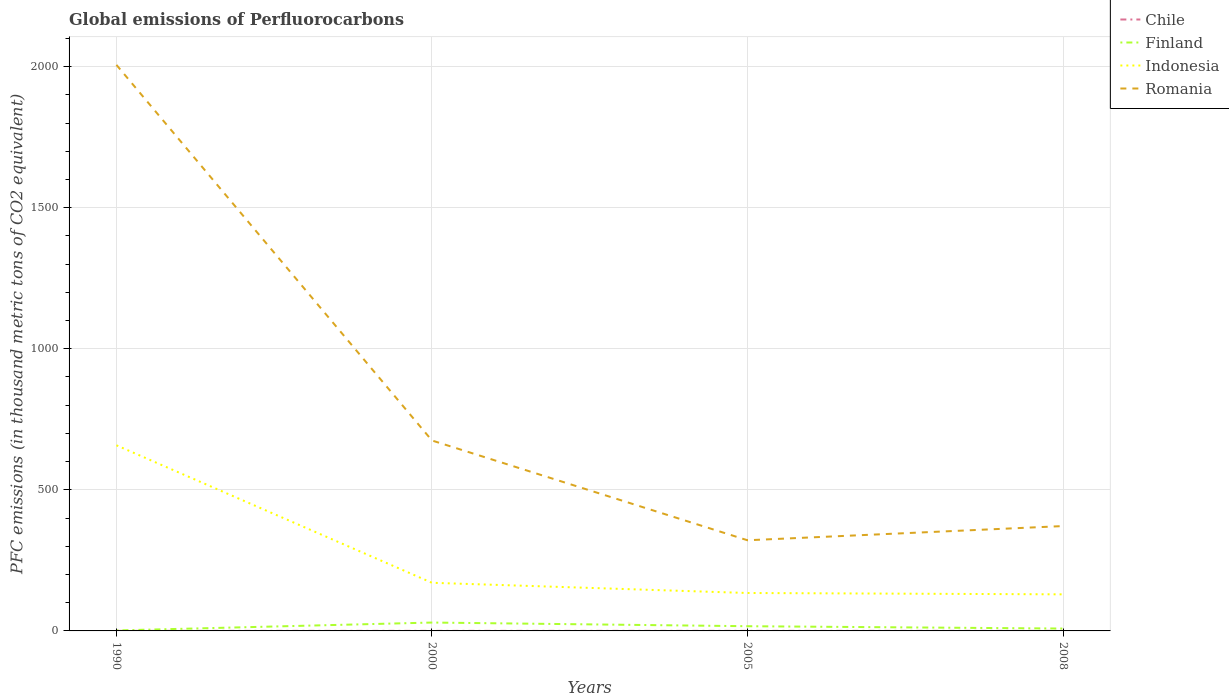How many different coloured lines are there?
Provide a short and direct response. 4. What is the total global emissions of Perfluorocarbons in Romania in the graph?
Your response must be concise. 353.6. What is the difference between the highest and the second highest global emissions of Perfluorocarbons in Finland?
Offer a terse response. 28. What is the difference between the highest and the lowest global emissions of Perfluorocarbons in Finland?
Keep it short and to the point. 2. How many lines are there?
Ensure brevity in your answer.  4. What is the difference between two consecutive major ticks on the Y-axis?
Your response must be concise. 500. Does the graph contain any zero values?
Ensure brevity in your answer.  No. What is the title of the graph?
Your response must be concise. Global emissions of Perfluorocarbons. What is the label or title of the X-axis?
Give a very brief answer. Years. What is the label or title of the Y-axis?
Offer a terse response. PFC emissions (in thousand metric tons of CO2 equivalent). What is the PFC emissions (in thousand metric tons of CO2 equivalent) in Chile in 1990?
Ensure brevity in your answer.  0.2. What is the PFC emissions (in thousand metric tons of CO2 equivalent) in Finland in 1990?
Keep it short and to the point. 1.7. What is the PFC emissions (in thousand metric tons of CO2 equivalent) in Indonesia in 1990?
Offer a very short reply. 657.9. What is the PFC emissions (in thousand metric tons of CO2 equivalent) of Romania in 1990?
Make the answer very short. 2006.1. What is the PFC emissions (in thousand metric tons of CO2 equivalent) of Chile in 2000?
Your answer should be very brief. 0.2. What is the PFC emissions (in thousand metric tons of CO2 equivalent) in Finland in 2000?
Your answer should be very brief. 29.7. What is the PFC emissions (in thousand metric tons of CO2 equivalent) of Indonesia in 2000?
Your answer should be compact. 170.6. What is the PFC emissions (in thousand metric tons of CO2 equivalent) in Romania in 2000?
Provide a short and direct response. 674.9. What is the PFC emissions (in thousand metric tons of CO2 equivalent) in Chile in 2005?
Your answer should be compact. 0.2. What is the PFC emissions (in thousand metric tons of CO2 equivalent) in Indonesia in 2005?
Your answer should be compact. 134.4. What is the PFC emissions (in thousand metric tons of CO2 equivalent) of Romania in 2005?
Ensure brevity in your answer.  321.3. What is the PFC emissions (in thousand metric tons of CO2 equivalent) of Finland in 2008?
Keep it short and to the point. 8.4. What is the PFC emissions (in thousand metric tons of CO2 equivalent) in Indonesia in 2008?
Give a very brief answer. 129.6. What is the PFC emissions (in thousand metric tons of CO2 equivalent) in Romania in 2008?
Provide a short and direct response. 371.6. Across all years, what is the maximum PFC emissions (in thousand metric tons of CO2 equivalent) in Chile?
Ensure brevity in your answer.  0.2. Across all years, what is the maximum PFC emissions (in thousand metric tons of CO2 equivalent) in Finland?
Ensure brevity in your answer.  29.7. Across all years, what is the maximum PFC emissions (in thousand metric tons of CO2 equivalent) in Indonesia?
Provide a short and direct response. 657.9. Across all years, what is the maximum PFC emissions (in thousand metric tons of CO2 equivalent) of Romania?
Keep it short and to the point. 2006.1. Across all years, what is the minimum PFC emissions (in thousand metric tons of CO2 equivalent) in Chile?
Your answer should be very brief. 0.2. Across all years, what is the minimum PFC emissions (in thousand metric tons of CO2 equivalent) of Finland?
Offer a very short reply. 1.7. Across all years, what is the minimum PFC emissions (in thousand metric tons of CO2 equivalent) of Indonesia?
Keep it short and to the point. 129.6. Across all years, what is the minimum PFC emissions (in thousand metric tons of CO2 equivalent) in Romania?
Offer a terse response. 321.3. What is the total PFC emissions (in thousand metric tons of CO2 equivalent) in Chile in the graph?
Your response must be concise. 0.8. What is the total PFC emissions (in thousand metric tons of CO2 equivalent) of Finland in the graph?
Make the answer very short. 56.5. What is the total PFC emissions (in thousand metric tons of CO2 equivalent) of Indonesia in the graph?
Keep it short and to the point. 1092.5. What is the total PFC emissions (in thousand metric tons of CO2 equivalent) in Romania in the graph?
Give a very brief answer. 3373.9. What is the difference between the PFC emissions (in thousand metric tons of CO2 equivalent) in Finland in 1990 and that in 2000?
Provide a succinct answer. -28. What is the difference between the PFC emissions (in thousand metric tons of CO2 equivalent) of Indonesia in 1990 and that in 2000?
Provide a short and direct response. 487.3. What is the difference between the PFC emissions (in thousand metric tons of CO2 equivalent) in Romania in 1990 and that in 2000?
Make the answer very short. 1331.2. What is the difference between the PFC emissions (in thousand metric tons of CO2 equivalent) in Chile in 1990 and that in 2005?
Your answer should be very brief. 0. What is the difference between the PFC emissions (in thousand metric tons of CO2 equivalent) in Finland in 1990 and that in 2005?
Your response must be concise. -15. What is the difference between the PFC emissions (in thousand metric tons of CO2 equivalent) of Indonesia in 1990 and that in 2005?
Provide a short and direct response. 523.5. What is the difference between the PFC emissions (in thousand metric tons of CO2 equivalent) of Romania in 1990 and that in 2005?
Provide a short and direct response. 1684.8. What is the difference between the PFC emissions (in thousand metric tons of CO2 equivalent) in Finland in 1990 and that in 2008?
Keep it short and to the point. -6.7. What is the difference between the PFC emissions (in thousand metric tons of CO2 equivalent) of Indonesia in 1990 and that in 2008?
Ensure brevity in your answer.  528.3. What is the difference between the PFC emissions (in thousand metric tons of CO2 equivalent) of Romania in 1990 and that in 2008?
Ensure brevity in your answer.  1634.5. What is the difference between the PFC emissions (in thousand metric tons of CO2 equivalent) in Indonesia in 2000 and that in 2005?
Provide a succinct answer. 36.2. What is the difference between the PFC emissions (in thousand metric tons of CO2 equivalent) of Romania in 2000 and that in 2005?
Your answer should be compact. 353.6. What is the difference between the PFC emissions (in thousand metric tons of CO2 equivalent) of Finland in 2000 and that in 2008?
Your response must be concise. 21.3. What is the difference between the PFC emissions (in thousand metric tons of CO2 equivalent) of Indonesia in 2000 and that in 2008?
Provide a succinct answer. 41. What is the difference between the PFC emissions (in thousand metric tons of CO2 equivalent) of Romania in 2000 and that in 2008?
Provide a succinct answer. 303.3. What is the difference between the PFC emissions (in thousand metric tons of CO2 equivalent) of Chile in 2005 and that in 2008?
Make the answer very short. 0. What is the difference between the PFC emissions (in thousand metric tons of CO2 equivalent) of Finland in 2005 and that in 2008?
Your response must be concise. 8.3. What is the difference between the PFC emissions (in thousand metric tons of CO2 equivalent) of Romania in 2005 and that in 2008?
Your answer should be very brief. -50.3. What is the difference between the PFC emissions (in thousand metric tons of CO2 equivalent) in Chile in 1990 and the PFC emissions (in thousand metric tons of CO2 equivalent) in Finland in 2000?
Provide a short and direct response. -29.5. What is the difference between the PFC emissions (in thousand metric tons of CO2 equivalent) in Chile in 1990 and the PFC emissions (in thousand metric tons of CO2 equivalent) in Indonesia in 2000?
Offer a very short reply. -170.4. What is the difference between the PFC emissions (in thousand metric tons of CO2 equivalent) in Chile in 1990 and the PFC emissions (in thousand metric tons of CO2 equivalent) in Romania in 2000?
Ensure brevity in your answer.  -674.7. What is the difference between the PFC emissions (in thousand metric tons of CO2 equivalent) in Finland in 1990 and the PFC emissions (in thousand metric tons of CO2 equivalent) in Indonesia in 2000?
Your answer should be very brief. -168.9. What is the difference between the PFC emissions (in thousand metric tons of CO2 equivalent) of Finland in 1990 and the PFC emissions (in thousand metric tons of CO2 equivalent) of Romania in 2000?
Keep it short and to the point. -673.2. What is the difference between the PFC emissions (in thousand metric tons of CO2 equivalent) of Chile in 1990 and the PFC emissions (in thousand metric tons of CO2 equivalent) of Finland in 2005?
Offer a very short reply. -16.5. What is the difference between the PFC emissions (in thousand metric tons of CO2 equivalent) of Chile in 1990 and the PFC emissions (in thousand metric tons of CO2 equivalent) of Indonesia in 2005?
Provide a short and direct response. -134.2. What is the difference between the PFC emissions (in thousand metric tons of CO2 equivalent) of Chile in 1990 and the PFC emissions (in thousand metric tons of CO2 equivalent) of Romania in 2005?
Keep it short and to the point. -321.1. What is the difference between the PFC emissions (in thousand metric tons of CO2 equivalent) of Finland in 1990 and the PFC emissions (in thousand metric tons of CO2 equivalent) of Indonesia in 2005?
Your response must be concise. -132.7. What is the difference between the PFC emissions (in thousand metric tons of CO2 equivalent) in Finland in 1990 and the PFC emissions (in thousand metric tons of CO2 equivalent) in Romania in 2005?
Provide a short and direct response. -319.6. What is the difference between the PFC emissions (in thousand metric tons of CO2 equivalent) in Indonesia in 1990 and the PFC emissions (in thousand metric tons of CO2 equivalent) in Romania in 2005?
Provide a succinct answer. 336.6. What is the difference between the PFC emissions (in thousand metric tons of CO2 equivalent) of Chile in 1990 and the PFC emissions (in thousand metric tons of CO2 equivalent) of Indonesia in 2008?
Keep it short and to the point. -129.4. What is the difference between the PFC emissions (in thousand metric tons of CO2 equivalent) of Chile in 1990 and the PFC emissions (in thousand metric tons of CO2 equivalent) of Romania in 2008?
Ensure brevity in your answer.  -371.4. What is the difference between the PFC emissions (in thousand metric tons of CO2 equivalent) of Finland in 1990 and the PFC emissions (in thousand metric tons of CO2 equivalent) of Indonesia in 2008?
Keep it short and to the point. -127.9. What is the difference between the PFC emissions (in thousand metric tons of CO2 equivalent) of Finland in 1990 and the PFC emissions (in thousand metric tons of CO2 equivalent) of Romania in 2008?
Offer a very short reply. -369.9. What is the difference between the PFC emissions (in thousand metric tons of CO2 equivalent) in Indonesia in 1990 and the PFC emissions (in thousand metric tons of CO2 equivalent) in Romania in 2008?
Offer a terse response. 286.3. What is the difference between the PFC emissions (in thousand metric tons of CO2 equivalent) of Chile in 2000 and the PFC emissions (in thousand metric tons of CO2 equivalent) of Finland in 2005?
Provide a succinct answer. -16.5. What is the difference between the PFC emissions (in thousand metric tons of CO2 equivalent) of Chile in 2000 and the PFC emissions (in thousand metric tons of CO2 equivalent) of Indonesia in 2005?
Your response must be concise. -134.2. What is the difference between the PFC emissions (in thousand metric tons of CO2 equivalent) of Chile in 2000 and the PFC emissions (in thousand metric tons of CO2 equivalent) of Romania in 2005?
Your answer should be very brief. -321.1. What is the difference between the PFC emissions (in thousand metric tons of CO2 equivalent) in Finland in 2000 and the PFC emissions (in thousand metric tons of CO2 equivalent) in Indonesia in 2005?
Your answer should be very brief. -104.7. What is the difference between the PFC emissions (in thousand metric tons of CO2 equivalent) of Finland in 2000 and the PFC emissions (in thousand metric tons of CO2 equivalent) of Romania in 2005?
Give a very brief answer. -291.6. What is the difference between the PFC emissions (in thousand metric tons of CO2 equivalent) of Indonesia in 2000 and the PFC emissions (in thousand metric tons of CO2 equivalent) of Romania in 2005?
Your answer should be compact. -150.7. What is the difference between the PFC emissions (in thousand metric tons of CO2 equivalent) of Chile in 2000 and the PFC emissions (in thousand metric tons of CO2 equivalent) of Indonesia in 2008?
Provide a short and direct response. -129.4. What is the difference between the PFC emissions (in thousand metric tons of CO2 equivalent) of Chile in 2000 and the PFC emissions (in thousand metric tons of CO2 equivalent) of Romania in 2008?
Give a very brief answer. -371.4. What is the difference between the PFC emissions (in thousand metric tons of CO2 equivalent) in Finland in 2000 and the PFC emissions (in thousand metric tons of CO2 equivalent) in Indonesia in 2008?
Provide a short and direct response. -99.9. What is the difference between the PFC emissions (in thousand metric tons of CO2 equivalent) in Finland in 2000 and the PFC emissions (in thousand metric tons of CO2 equivalent) in Romania in 2008?
Offer a terse response. -341.9. What is the difference between the PFC emissions (in thousand metric tons of CO2 equivalent) in Indonesia in 2000 and the PFC emissions (in thousand metric tons of CO2 equivalent) in Romania in 2008?
Provide a succinct answer. -201. What is the difference between the PFC emissions (in thousand metric tons of CO2 equivalent) in Chile in 2005 and the PFC emissions (in thousand metric tons of CO2 equivalent) in Indonesia in 2008?
Offer a terse response. -129.4. What is the difference between the PFC emissions (in thousand metric tons of CO2 equivalent) in Chile in 2005 and the PFC emissions (in thousand metric tons of CO2 equivalent) in Romania in 2008?
Your answer should be very brief. -371.4. What is the difference between the PFC emissions (in thousand metric tons of CO2 equivalent) in Finland in 2005 and the PFC emissions (in thousand metric tons of CO2 equivalent) in Indonesia in 2008?
Offer a terse response. -112.9. What is the difference between the PFC emissions (in thousand metric tons of CO2 equivalent) in Finland in 2005 and the PFC emissions (in thousand metric tons of CO2 equivalent) in Romania in 2008?
Make the answer very short. -354.9. What is the difference between the PFC emissions (in thousand metric tons of CO2 equivalent) of Indonesia in 2005 and the PFC emissions (in thousand metric tons of CO2 equivalent) of Romania in 2008?
Offer a very short reply. -237.2. What is the average PFC emissions (in thousand metric tons of CO2 equivalent) in Chile per year?
Keep it short and to the point. 0.2. What is the average PFC emissions (in thousand metric tons of CO2 equivalent) of Finland per year?
Ensure brevity in your answer.  14.12. What is the average PFC emissions (in thousand metric tons of CO2 equivalent) of Indonesia per year?
Provide a succinct answer. 273.12. What is the average PFC emissions (in thousand metric tons of CO2 equivalent) of Romania per year?
Make the answer very short. 843.48. In the year 1990, what is the difference between the PFC emissions (in thousand metric tons of CO2 equivalent) of Chile and PFC emissions (in thousand metric tons of CO2 equivalent) of Indonesia?
Offer a very short reply. -657.7. In the year 1990, what is the difference between the PFC emissions (in thousand metric tons of CO2 equivalent) of Chile and PFC emissions (in thousand metric tons of CO2 equivalent) of Romania?
Give a very brief answer. -2005.9. In the year 1990, what is the difference between the PFC emissions (in thousand metric tons of CO2 equivalent) in Finland and PFC emissions (in thousand metric tons of CO2 equivalent) in Indonesia?
Keep it short and to the point. -656.2. In the year 1990, what is the difference between the PFC emissions (in thousand metric tons of CO2 equivalent) of Finland and PFC emissions (in thousand metric tons of CO2 equivalent) of Romania?
Provide a succinct answer. -2004.4. In the year 1990, what is the difference between the PFC emissions (in thousand metric tons of CO2 equivalent) of Indonesia and PFC emissions (in thousand metric tons of CO2 equivalent) of Romania?
Provide a short and direct response. -1348.2. In the year 2000, what is the difference between the PFC emissions (in thousand metric tons of CO2 equivalent) of Chile and PFC emissions (in thousand metric tons of CO2 equivalent) of Finland?
Your response must be concise. -29.5. In the year 2000, what is the difference between the PFC emissions (in thousand metric tons of CO2 equivalent) of Chile and PFC emissions (in thousand metric tons of CO2 equivalent) of Indonesia?
Make the answer very short. -170.4. In the year 2000, what is the difference between the PFC emissions (in thousand metric tons of CO2 equivalent) of Chile and PFC emissions (in thousand metric tons of CO2 equivalent) of Romania?
Provide a short and direct response. -674.7. In the year 2000, what is the difference between the PFC emissions (in thousand metric tons of CO2 equivalent) of Finland and PFC emissions (in thousand metric tons of CO2 equivalent) of Indonesia?
Ensure brevity in your answer.  -140.9. In the year 2000, what is the difference between the PFC emissions (in thousand metric tons of CO2 equivalent) in Finland and PFC emissions (in thousand metric tons of CO2 equivalent) in Romania?
Give a very brief answer. -645.2. In the year 2000, what is the difference between the PFC emissions (in thousand metric tons of CO2 equivalent) of Indonesia and PFC emissions (in thousand metric tons of CO2 equivalent) of Romania?
Provide a short and direct response. -504.3. In the year 2005, what is the difference between the PFC emissions (in thousand metric tons of CO2 equivalent) of Chile and PFC emissions (in thousand metric tons of CO2 equivalent) of Finland?
Provide a succinct answer. -16.5. In the year 2005, what is the difference between the PFC emissions (in thousand metric tons of CO2 equivalent) of Chile and PFC emissions (in thousand metric tons of CO2 equivalent) of Indonesia?
Give a very brief answer. -134.2. In the year 2005, what is the difference between the PFC emissions (in thousand metric tons of CO2 equivalent) of Chile and PFC emissions (in thousand metric tons of CO2 equivalent) of Romania?
Offer a very short reply. -321.1. In the year 2005, what is the difference between the PFC emissions (in thousand metric tons of CO2 equivalent) of Finland and PFC emissions (in thousand metric tons of CO2 equivalent) of Indonesia?
Your answer should be very brief. -117.7. In the year 2005, what is the difference between the PFC emissions (in thousand metric tons of CO2 equivalent) of Finland and PFC emissions (in thousand metric tons of CO2 equivalent) of Romania?
Give a very brief answer. -304.6. In the year 2005, what is the difference between the PFC emissions (in thousand metric tons of CO2 equivalent) in Indonesia and PFC emissions (in thousand metric tons of CO2 equivalent) in Romania?
Your answer should be compact. -186.9. In the year 2008, what is the difference between the PFC emissions (in thousand metric tons of CO2 equivalent) in Chile and PFC emissions (in thousand metric tons of CO2 equivalent) in Indonesia?
Keep it short and to the point. -129.4. In the year 2008, what is the difference between the PFC emissions (in thousand metric tons of CO2 equivalent) in Chile and PFC emissions (in thousand metric tons of CO2 equivalent) in Romania?
Keep it short and to the point. -371.4. In the year 2008, what is the difference between the PFC emissions (in thousand metric tons of CO2 equivalent) of Finland and PFC emissions (in thousand metric tons of CO2 equivalent) of Indonesia?
Ensure brevity in your answer.  -121.2. In the year 2008, what is the difference between the PFC emissions (in thousand metric tons of CO2 equivalent) in Finland and PFC emissions (in thousand metric tons of CO2 equivalent) in Romania?
Make the answer very short. -363.2. In the year 2008, what is the difference between the PFC emissions (in thousand metric tons of CO2 equivalent) of Indonesia and PFC emissions (in thousand metric tons of CO2 equivalent) of Romania?
Ensure brevity in your answer.  -242. What is the ratio of the PFC emissions (in thousand metric tons of CO2 equivalent) of Chile in 1990 to that in 2000?
Keep it short and to the point. 1. What is the ratio of the PFC emissions (in thousand metric tons of CO2 equivalent) of Finland in 1990 to that in 2000?
Offer a very short reply. 0.06. What is the ratio of the PFC emissions (in thousand metric tons of CO2 equivalent) of Indonesia in 1990 to that in 2000?
Keep it short and to the point. 3.86. What is the ratio of the PFC emissions (in thousand metric tons of CO2 equivalent) in Romania in 1990 to that in 2000?
Your answer should be very brief. 2.97. What is the ratio of the PFC emissions (in thousand metric tons of CO2 equivalent) in Chile in 1990 to that in 2005?
Your response must be concise. 1. What is the ratio of the PFC emissions (in thousand metric tons of CO2 equivalent) of Finland in 1990 to that in 2005?
Ensure brevity in your answer.  0.1. What is the ratio of the PFC emissions (in thousand metric tons of CO2 equivalent) of Indonesia in 1990 to that in 2005?
Provide a succinct answer. 4.9. What is the ratio of the PFC emissions (in thousand metric tons of CO2 equivalent) in Romania in 1990 to that in 2005?
Your answer should be very brief. 6.24. What is the ratio of the PFC emissions (in thousand metric tons of CO2 equivalent) in Chile in 1990 to that in 2008?
Your response must be concise. 1. What is the ratio of the PFC emissions (in thousand metric tons of CO2 equivalent) in Finland in 1990 to that in 2008?
Give a very brief answer. 0.2. What is the ratio of the PFC emissions (in thousand metric tons of CO2 equivalent) of Indonesia in 1990 to that in 2008?
Offer a terse response. 5.08. What is the ratio of the PFC emissions (in thousand metric tons of CO2 equivalent) in Romania in 1990 to that in 2008?
Offer a terse response. 5.4. What is the ratio of the PFC emissions (in thousand metric tons of CO2 equivalent) of Chile in 2000 to that in 2005?
Provide a short and direct response. 1. What is the ratio of the PFC emissions (in thousand metric tons of CO2 equivalent) of Finland in 2000 to that in 2005?
Provide a succinct answer. 1.78. What is the ratio of the PFC emissions (in thousand metric tons of CO2 equivalent) in Indonesia in 2000 to that in 2005?
Keep it short and to the point. 1.27. What is the ratio of the PFC emissions (in thousand metric tons of CO2 equivalent) in Romania in 2000 to that in 2005?
Offer a very short reply. 2.1. What is the ratio of the PFC emissions (in thousand metric tons of CO2 equivalent) in Finland in 2000 to that in 2008?
Offer a very short reply. 3.54. What is the ratio of the PFC emissions (in thousand metric tons of CO2 equivalent) of Indonesia in 2000 to that in 2008?
Provide a succinct answer. 1.32. What is the ratio of the PFC emissions (in thousand metric tons of CO2 equivalent) in Romania in 2000 to that in 2008?
Provide a short and direct response. 1.82. What is the ratio of the PFC emissions (in thousand metric tons of CO2 equivalent) of Finland in 2005 to that in 2008?
Give a very brief answer. 1.99. What is the ratio of the PFC emissions (in thousand metric tons of CO2 equivalent) in Romania in 2005 to that in 2008?
Provide a succinct answer. 0.86. What is the difference between the highest and the second highest PFC emissions (in thousand metric tons of CO2 equivalent) of Finland?
Provide a short and direct response. 13. What is the difference between the highest and the second highest PFC emissions (in thousand metric tons of CO2 equivalent) of Indonesia?
Your response must be concise. 487.3. What is the difference between the highest and the second highest PFC emissions (in thousand metric tons of CO2 equivalent) in Romania?
Give a very brief answer. 1331.2. What is the difference between the highest and the lowest PFC emissions (in thousand metric tons of CO2 equivalent) in Chile?
Offer a terse response. 0. What is the difference between the highest and the lowest PFC emissions (in thousand metric tons of CO2 equivalent) in Indonesia?
Your answer should be very brief. 528.3. What is the difference between the highest and the lowest PFC emissions (in thousand metric tons of CO2 equivalent) of Romania?
Your answer should be compact. 1684.8. 